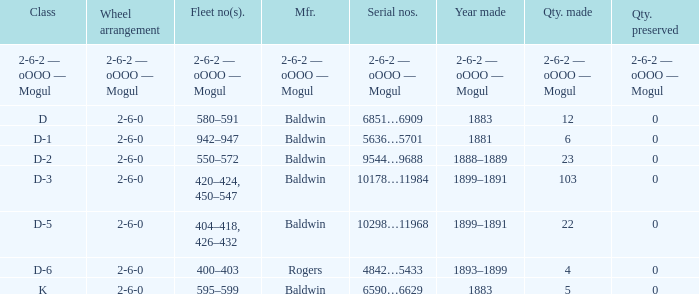What is the class when the quantity perserved is 0 and the quantity made is 5? K. 